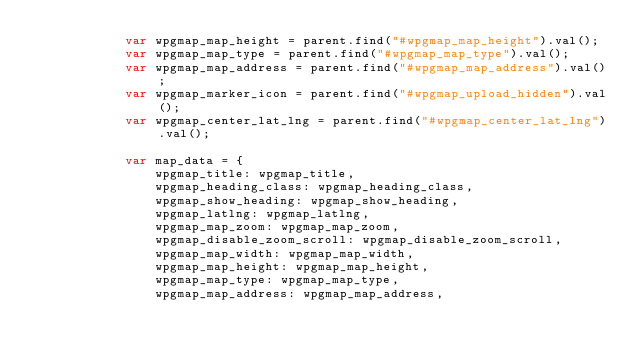<code> <loc_0><loc_0><loc_500><loc_500><_JavaScript_>            var wpgmap_map_height = parent.find("#wpgmap_map_height").val();
            var wpgmap_map_type = parent.find("#wpgmap_map_type").val();
            var wpgmap_map_address = parent.find("#wpgmap_map_address").val();
            var wpgmap_marker_icon = parent.find("#wpgmap_upload_hidden").val();
            var wpgmap_center_lat_lng = parent.find("#wpgmap_center_lat_lng").val();

            var map_data = {
                wpgmap_title: wpgmap_title,
                wpgmap_heading_class: wpgmap_heading_class,
                wpgmap_show_heading: wpgmap_show_heading,
                wpgmap_latlng: wpgmap_latlng,
                wpgmap_map_zoom: wpgmap_map_zoom,
                wpgmap_disable_zoom_scroll: wpgmap_disable_zoom_scroll,
                wpgmap_map_width: wpgmap_map_width,
                wpgmap_map_height: wpgmap_map_height,
                wpgmap_map_type: wpgmap_map_type,
                wpgmap_map_address: wpgmap_map_address,</code> 